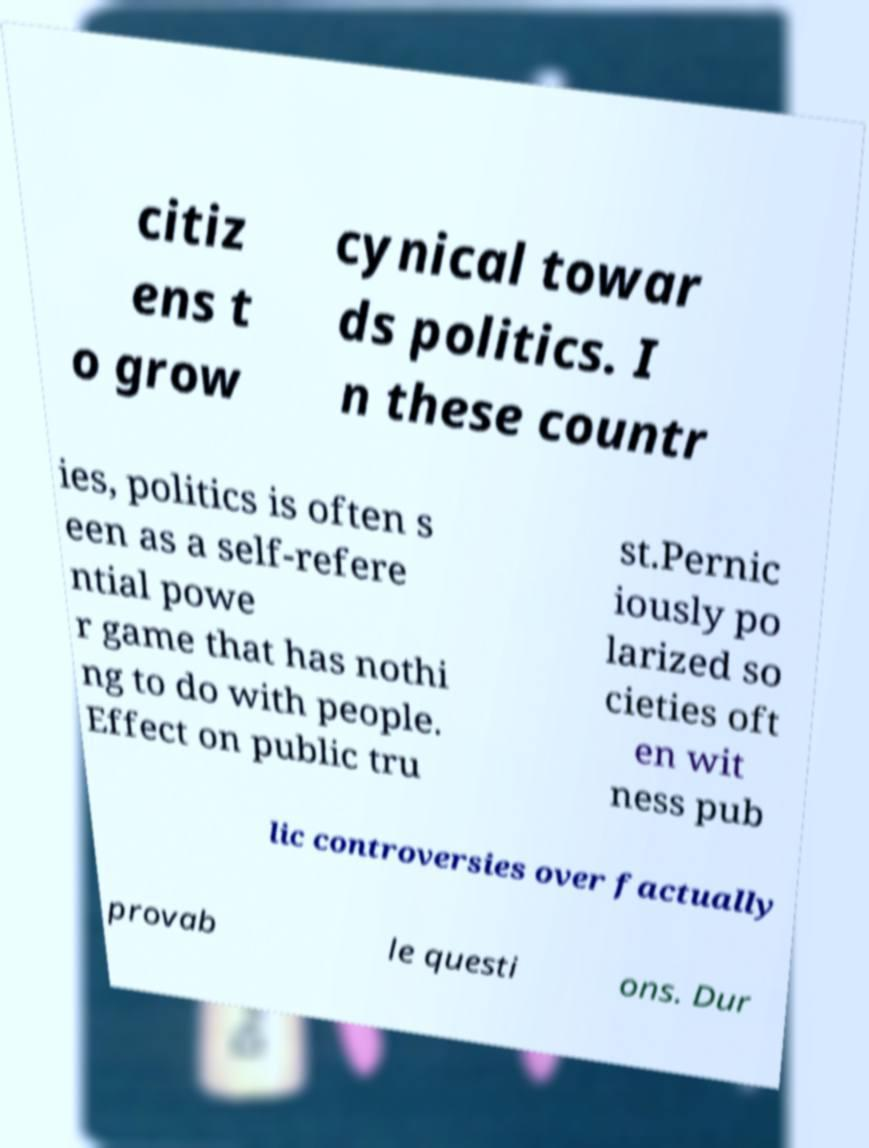Can you read and provide the text displayed in the image?This photo seems to have some interesting text. Can you extract and type it out for me? citiz ens t o grow cynical towar ds politics. I n these countr ies, politics is often s een as a self-refere ntial powe r game that has nothi ng to do with people. Effect on public tru st.Pernic iously po larized so cieties oft en wit ness pub lic controversies over factually provab le questi ons. Dur 